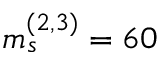<formula> <loc_0><loc_0><loc_500><loc_500>m _ { s } ^ { ( 2 , 3 ) } = 6 0</formula> 